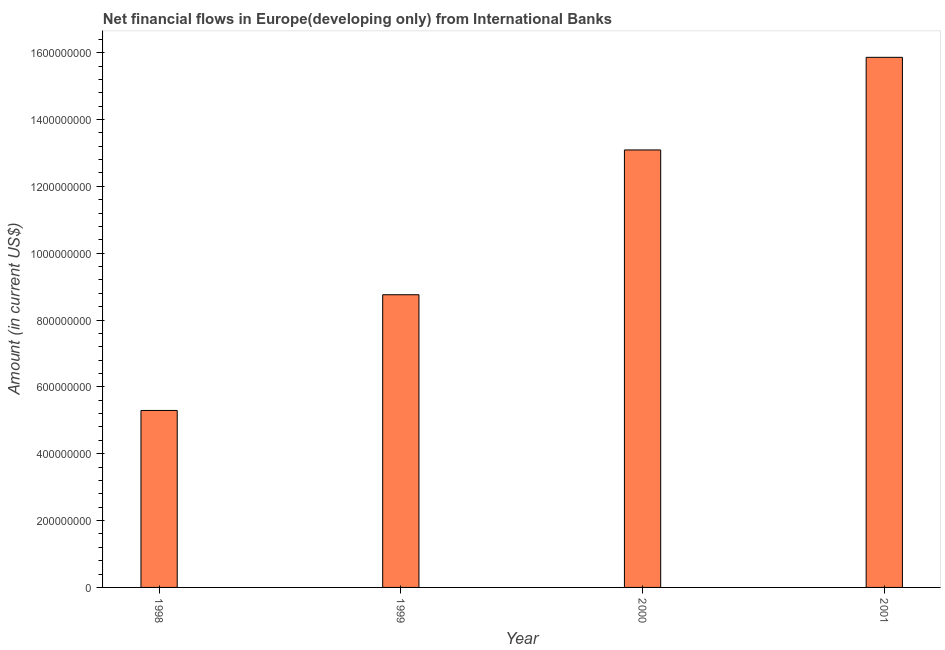Does the graph contain any zero values?
Keep it short and to the point. No. What is the title of the graph?
Ensure brevity in your answer.  Net financial flows in Europe(developing only) from International Banks. What is the label or title of the X-axis?
Your answer should be compact. Year. What is the net financial flows from ibrd in 1999?
Your response must be concise. 8.76e+08. Across all years, what is the maximum net financial flows from ibrd?
Your response must be concise. 1.59e+09. Across all years, what is the minimum net financial flows from ibrd?
Your answer should be very brief. 5.29e+08. What is the sum of the net financial flows from ibrd?
Your answer should be compact. 4.30e+09. What is the difference between the net financial flows from ibrd in 1999 and 2000?
Ensure brevity in your answer.  -4.33e+08. What is the average net financial flows from ibrd per year?
Offer a terse response. 1.07e+09. What is the median net financial flows from ibrd?
Make the answer very short. 1.09e+09. In how many years, is the net financial flows from ibrd greater than 400000000 US$?
Your answer should be compact. 4. Do a majority of the years between 1999 and 2000 (inclusive) have net financial flows from ibrd greater than 1520000000 US$?
Give a very brief answer. No. What is the ratio of the net financial flows from ibrd in 1999 to that in 2000?
Your response must be concise. 0.67. What is the difference between the highest and the second highest net financial flows from ibrd?
Keep it short and to the point. 2.77e+08. Is the sum of the net financial flows from ibrd in 1998 and 2001 greater than the maximum net financial flows from ibrd across all years?
Provide a short and direct response. Yes. What is the difference between the highest and the lowest net financial flows from ibrd?
Provide a short and direct response. 1.06e+09. In how many years, is the net financial flows from ibrd greater than the average net financial flows from ibrd taken over all years?
Offer a terse response. 2. How many bars are there?
Your answer should be very brief. 4. Are all the bars in the graph horizontal?
Ensure brevity in your answer.  No. How many years are there in the graph?
Your answer should be compact. 4. What is the difference between two consecutive major ticks on the Y-axis?
Offer a very short reply. 2.00e+08. Are the values on the major ticks of Y-axis written in scientific E-notation?
Provide a short and direct response. No. What is the Amount (in current US$) of 1998?
Make the answer very short. 5.29e+08. What is the Amount (in current US$) in 1999?
Ensure brevity in your answer.  8.76e+08. What is the Amount (in current US$) in 2000?
Provide a succinct answer. 1.31e+09. What is the Amount (in current US$) of 2001?
Your answer should be very brief. 1.59e+09. What is the difference between the Amount (in current US$) in 1998 and 1999?
Offer a terse response. -3.46e+08. What is the difference between the Amount (in current US$) in 1998 and 2000?
Your response must be concise. -7.79e+08. What is the difference between the Amount (in current US$) in 1998 and 2001?
Offer a very short reply. -1.06e+09. What is the difference between the Amount (in current US$) in 1999 and 2000?
Offer a terse response. -4.33e+08. What is the difference between the Amount (in current US$) in 1999 and 2001?
Keep it short and to the point. -7.10e+08. What is the difference between the Amount (in current US$) in 2000 and 2001?
Keep it short and to the point. -2.77e+08. What is the ratio of the Amount (in current US$) in 1998 to that in 1999?
Make the answer very short. 0.6. What is the ratio of the Amount (in current US$) in 1998 to that in 2000?
Provide a succinct answer. 0.4. What is the ratio of the Amount (in current US$) in 1998 to that in 2001?
Your answer should be compact. 0.33. What is the ratio of the Amount (in current US$) in 1999 to that in 2000?
Ensure brevity in your answer.  0.67. What is the ratio of the Amount (in current US$) in 1999 to that in 2001?
Offer a terse response. 0.55. What is the ratio of the Amount (in current US$) in 2000 to that in 2001?
Provide a succinct answer. 0.82. 